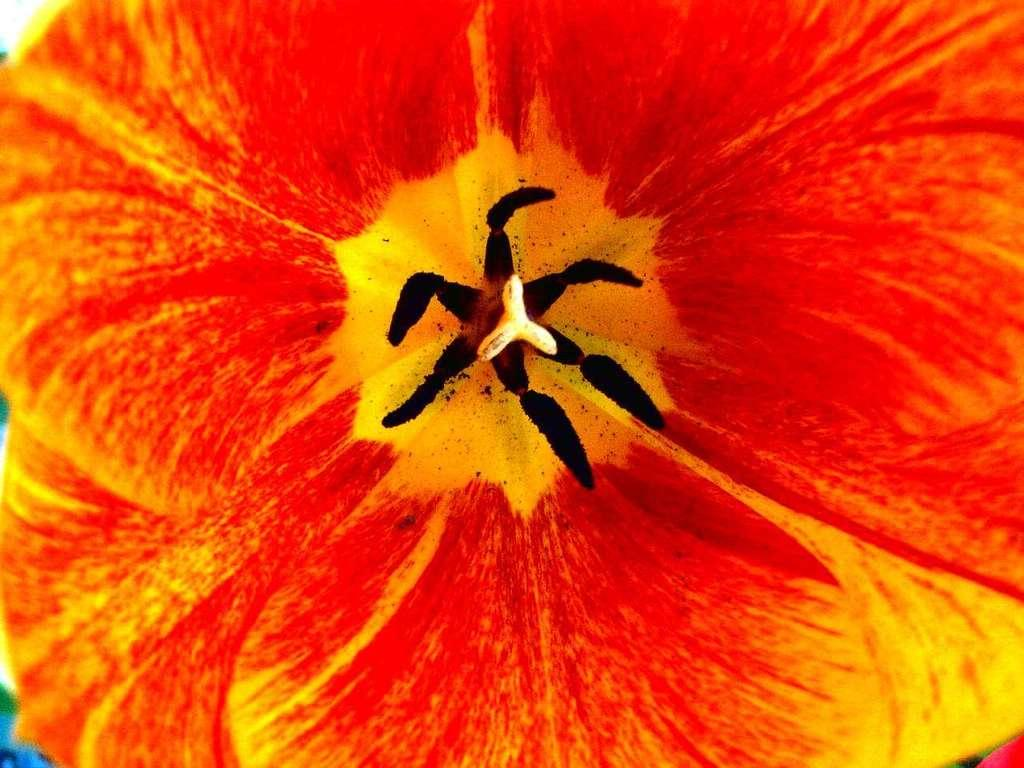What is the main subject of the image? There is a flower in the image. Can you describe the color of the flower? The flower has an orange and red color combination. How would you describe the background of the image? The background of the image is blurred. How does the flower walk around in the image? Flowers do not walk; they are stationary plants. The flower in the image is not depicted as moving or walking. 